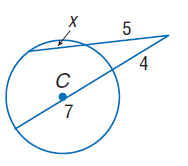Question: Find x. Assume that segments that appear to be tangent are tangent.
Choices:
A. 3.8
B. 4
C. 5
D. 7
Answer with the letter. Answer: A 